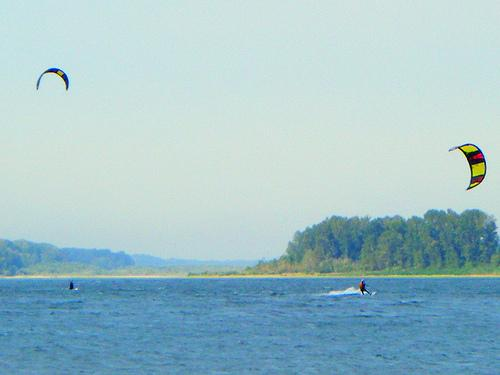What kind of day is it and what are people doing in the water? It's a clear day with good visibility, and there are people kiteboarding on the water. List the main elements visible in the image, including the backdrop and the main action happening. The main elements in the image include kiteboarders, colorful kites, blue water, distant trees, and a clear sky. Visualize being in the scene and describe the surroundings and the activities taking place. Standing on the shore, you would see kiteboarders swiftly moving across the water, propelled by colorful kites, with a backdrop of distant greenery and a clear blue sky. Mention the main activity happening in the photograph and the people involved. The main activity is kiteboarding, involving individuals maneuvering across the water using kites. Highlight the contrast between the objects in the image and the background in terms of color and activity. The bright colors of the kites contrast sharply with the natural blue of the water and the muted colors of the distant foliage and clear sky. Provide a brief summary of the central theme of the image. The image captures the dynamic sport of kiteboarding on a clear day, showcasing the interaction between humans and nature. Write a sentence describing the environment where the photo was taken. The photo was taken at a large body of water, characterized by clear skies and a natural, tree-lined horizon. Describe the features of the main person in the image and the object he is holding on to. The main kiteboarder is wearing a dark wetsuit and is attached to a brightly colored kite, navigating the water. How would you describe the colors that dominate the image and the overall impression they create? Dominant colors include the blues of the water and sky, and the vibrant yellows and reds of the kites, creating a lively and energetic scene. What is the overall atmosphere of the image and how would you describe the weather? The overall atmosphere is vibrant and active, indicative of a pleasant and clear weather day, ideal for outdoor water sports. 